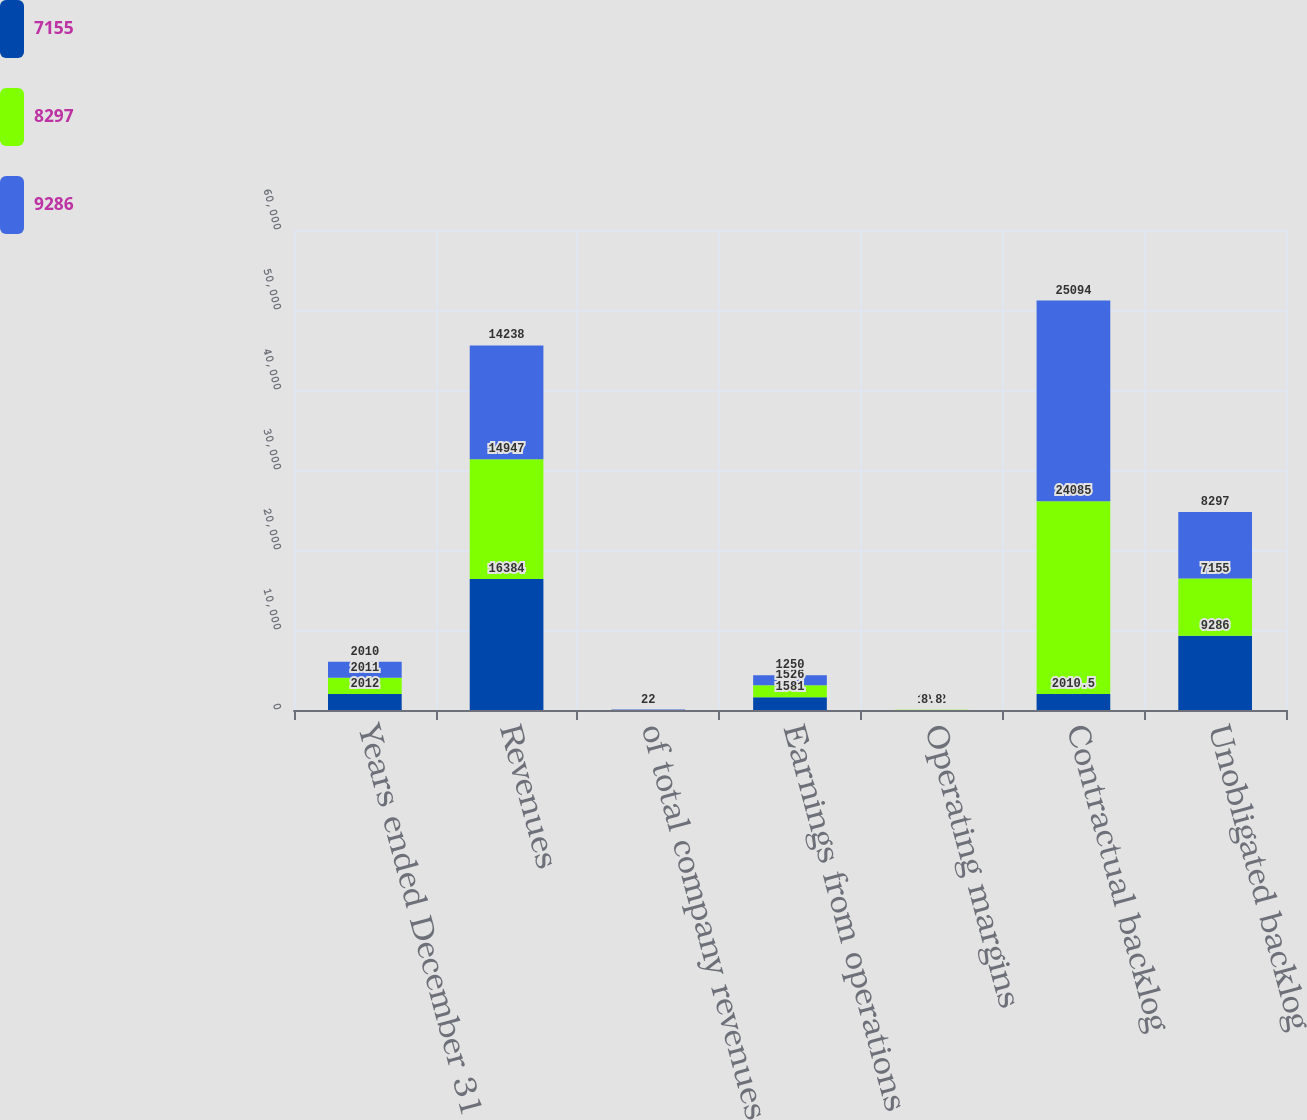<chart> <loc_0><loc_0><loc_500><loc_500><stacked_bar_chart><ecel><fcel>Years ended December 31<fcel>Revenues<fcel>of total company revenues<fcel>Earnings from operations<fcel>Operating margins<fcel>Contractual backlog<fcel>Unobligated backlog<nl><fcel>7155<fcel>2012<fcel>16384<fcel>20<fcel>1581<fcel>9.6<fcel>2010.5<fcel>9286<nl><fcel>8297<fcel>2011<fcel>14947<fcel>22<fcel>1526<fcel>10.2<fcel>24085<fcel>7155<nl><fcel>9286<fcel>2010<fcel>14238<fcel>22<fcel>1250<fcel>8.8<fcel>25094<fcel>8297<nl></chart> 